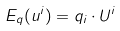<formula> <loc_0><loc_0><loc_500><loc_500>E _ { q } ( u ^ { i } ) = q _ { i } \cdot U ^ { i }</formula> 